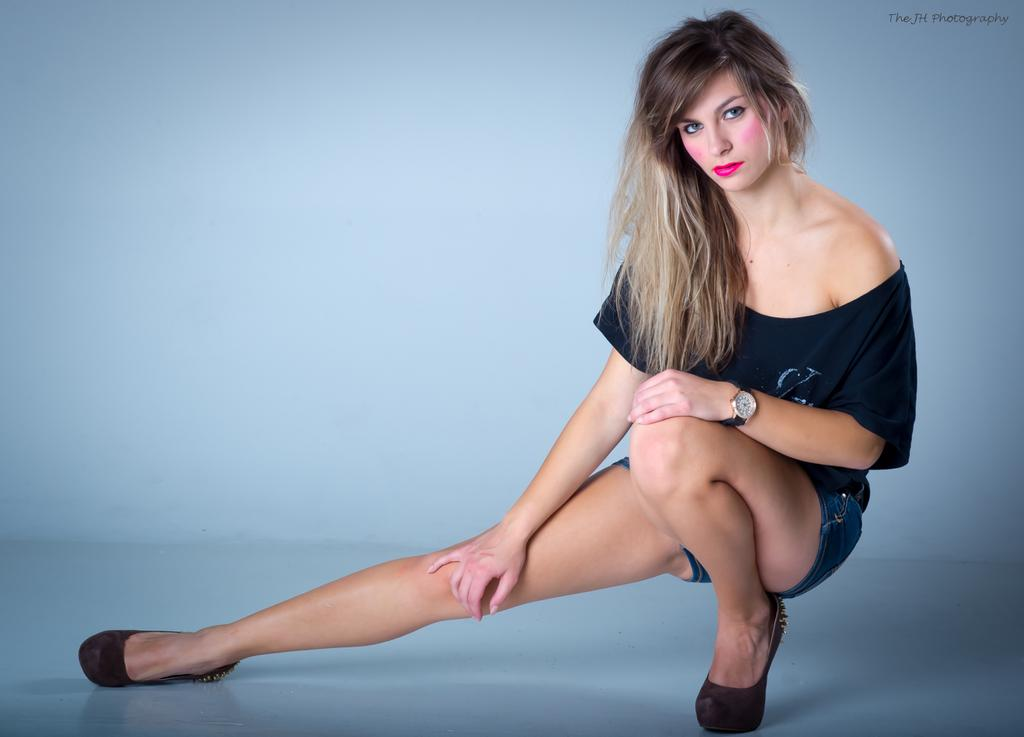Who is the main subject in the image? There is a woman in the image. Can you describe the woman's hair in the image? The woman has long hair. What is the woman wearing in the image? The woman is wearing a dress. What surface is the woman standing on in the image? The woman is standing on the floor. What type of territory is the woman trying to claim in the image? There is no indication in the image that the woman is trying to claim any territory. 